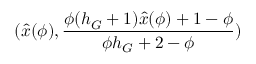<formula> <loc_0><loc_0><loc_500><loc_500>( \hat { x } ( \phi ) , \frac { \phi ( h _ { G } + 1 ) \hat { x } ( \phi ) + 1 - \phi } { \phi h _ { G } + 2 - \phi } )</formula> 